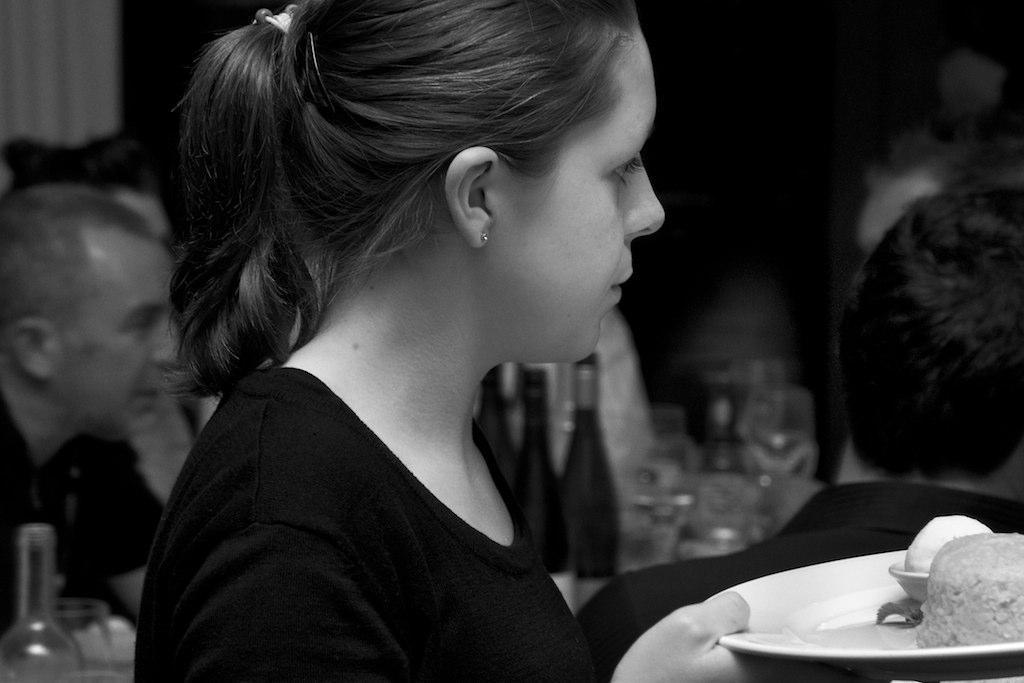Can you describe this image briefly? Here in the front we can see a woman having a plate of food in her hand and behind her we can see people sitting with Bottles And glasses present 